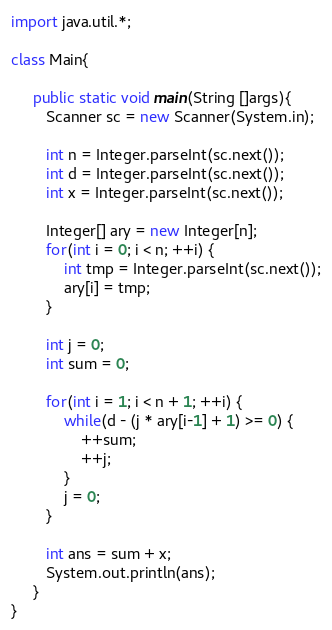Convert code to text. <code><loc_0><loc_0><loc_500><loc_500><_Java_>import java.util.*;

class Main{

     public static void main(String []args){
        Scanner sc = new Scanner(System.in);
        
        int n = Integer.parseInt(sc.next());
        int d = Integer.parseInt(sc.next());
        int x = Integer.parseInt(sc.next());
        
        Integer[] ary = new Integer[n];
        for(int i = 0; i < n; ++i) {
            int tmp = Integer.parseInt(sc.next());
            ary[i] = tmp;
        }
        
        int j = 0;
        int sum = 0;
        
        for(int i = 1; i < n + 1; ++i) {
            while(d - (j * ary[i-1] + 1) >= 0) {
                ++sum;
                ++j;
            }
            j = 0;
        }
        
        int ans = sum + x;
        System.out.println(ans);
     }
}</code> 